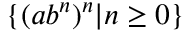<formula> <loc_0><loc_0><loc_500><loc_500>\{ ( a b ^ { n } ) ^ { n } | n \geq 0 \}</formula> 